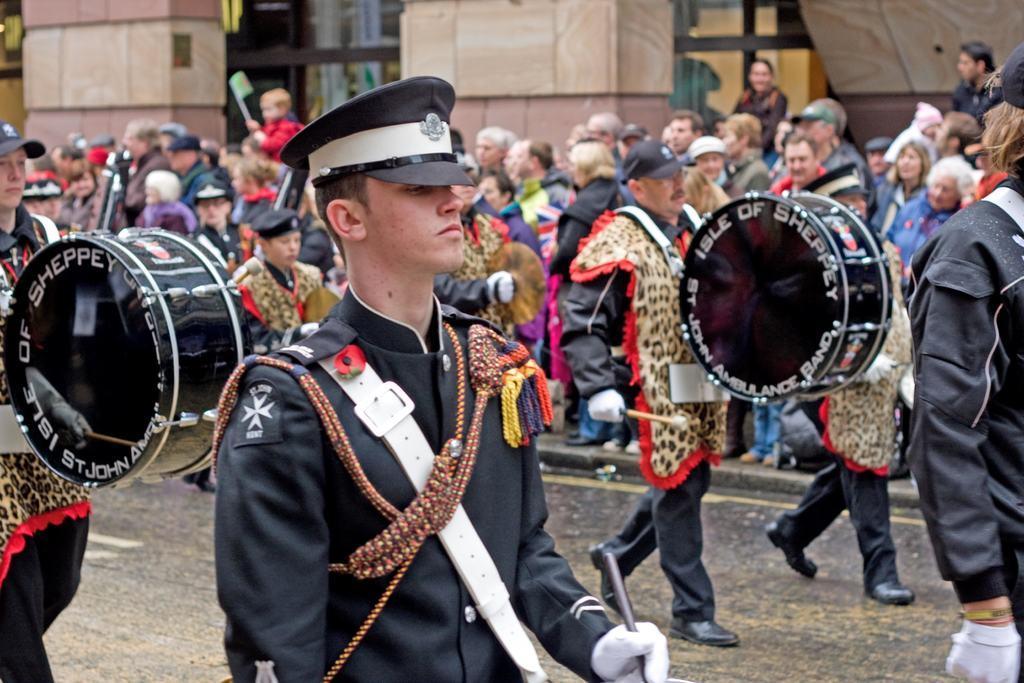How would you summarize this image in a sentence or two? In this picture we can see men wearing caps, playing drums and walking. On the background we can see building and few persons standing near to it. 